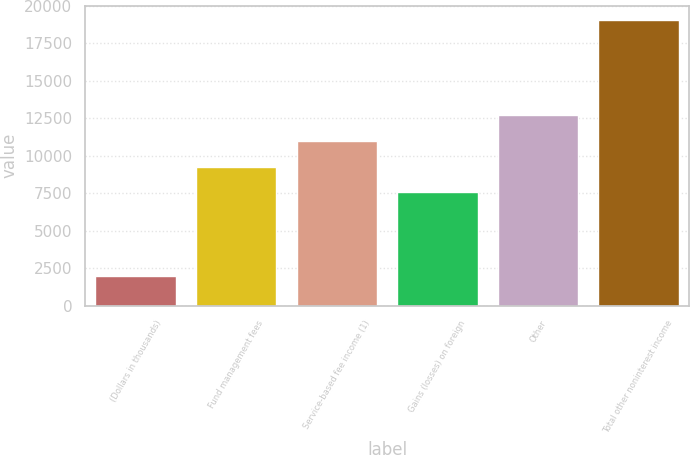Convert chart. <chart><loc_0><loc_0><loc_500><loc_500><bar_chart><fcel>(Dollars in thousands)<fcel>Fund management fees<fcel>Service-based fee income (1)<fcel>Gains (losses) on foreign<fcel>Other<fcel>Total other noninterest income<nl><fcel>2008<fcel>9271.4<fcel>10975.8<fcel>7567<fcel>12680.2<fcel>19052<nl></chart> 